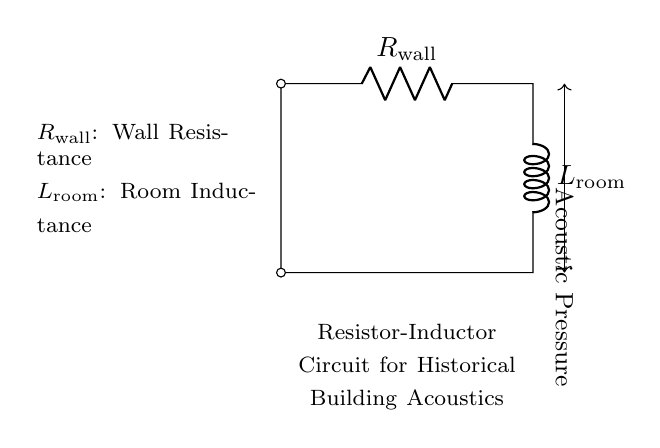What is the resistance value in the circuit? The circuit diagram shows a resistor labeled "R_{wall}" which represents the resistance of the wall in the historical building. The specific numerical value isn't given in the diagram, but it is denoted as R_{wall}.
Answer: R_{wall} What does L represent in the circuit? L in the circuit diagram stands for "L_{room}", which indicates the inductance associated with the room's acoustics, reflecting how the room's physical characteristics can affect sound.
Answer: L_{room} What is the acoustic property measured in this circuit? The circuit features an arrow indicating "Acoustic Pressure" which suggests that this is a measure of sound pressure levels within the simulated environment of the historical building.
Answer: Acoustic Pressure How are the resistor and inductor connected in the circuit? The resistor "R_{wall}" is in series with the inductor "L_{room}" as per the drawing. They are connected linearly, with the resistor followed directly by the inductor before returning to the starting point, indicating series connection.
Answer: Series What type of circuit is represented here? The circuit diagram represents a Resistor-Inductor circuit, as it includes both a resistor (R) and an inductor (L) functioning together to simulate the acoustic properties of a space.
Answer: Resistor-Inductor What role does the inductor play in this circuit? The inductor "L_{room}" impacts how the circuit responds to changes in current and potentially influences sound wave behavior, affecting the overall acoustic simulation of historical architecture.
Answer: Acoustics simulation 